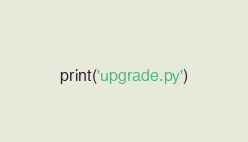Convert code to text. <code><loc_0><loc_0><loc_500><loc_500><_Python_>print('upgrade.py')
</code> 